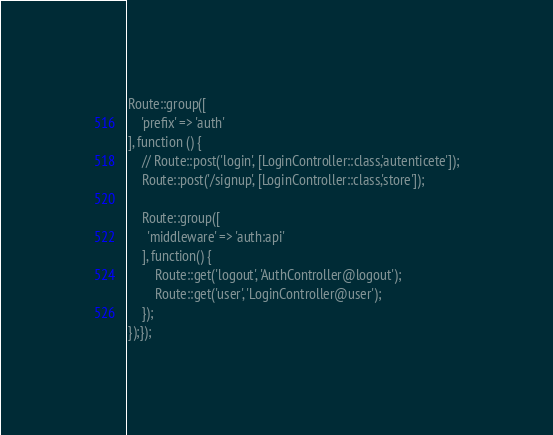<code> <loc_0><loc_0><loc_500><loc_500><_PHP_>Route::group([
    'prefix' => 'auth'
], function () {
    // Route::post('login', [LoginController::class,'autenticete']);
    Route::post('/signup', [LoginController::class,'store']);
  
    Route::group([
      'middleware' => 'auth:api'
    ], function() {
        Route::get('logout', 'AuthController@logout');
        Route::get('user', 'LoginController@user');
    });
});});
</code> 